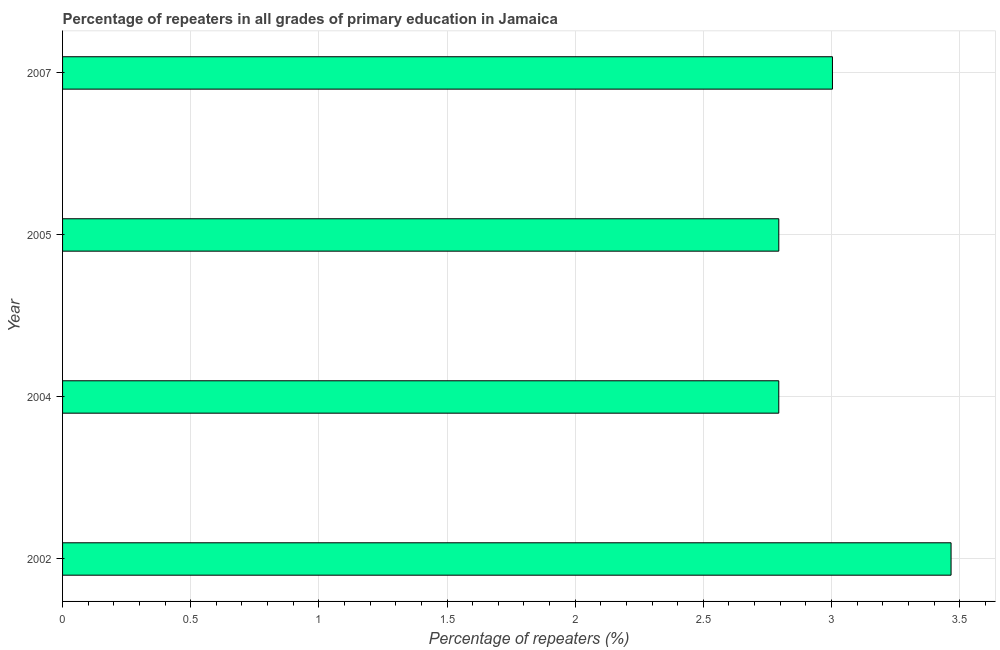What is the title of the graph?
Ensure brevity in your answer.  Percentage of repeaters in all grades of primary education in Jamaica. What is the label or title of the X-axis?
Keep it short and to the point. Percentage of repeaters (%). What is the percentage of repeaters in primary education in 2005?
Your answer should be compact. 2.79. Across all years, what is the maximum percentage of repeaters in primary education?
Keep it short and to the point. 3.47. Across all years, what is the minimum percentage of repeaters in primary education?
Make the answer very short. 2.79. In which year was the percentage of repeaters in primary education maximum?
Your answer should be compact. 2002. What is the sum of the percentage of repeaters in primary education?
Your response must be concise. 12.06. What is the difference between the percentage of repeaters in primary education in 2002 and 2005?
Offer a terse response. 0.67. What is the average percentage of repeaters in primary education per year?
Your answer should be compact. 3.02. What is the median percentage of repeaters in primary education?
Your answer should be compact. 2.9. What is the ratio of the percentage of repeaters in primary education in 2002 to that in 2004?
Make the answer very short. 1.24. Is the percentage of repeaters in primary education in 2002 less than that in 2007?
Offer a very short reply. No. Is the difference between the percentage of repeaters in primary education in 2004 and 2007 greater than the difference between any two years?
Offer a very short reply. No. What is the difference between the highest and the second highest percentage of repeaters in primary education?
Provide a short and direct response. 0.46. What is the difference between the highest and the lowest percentage of repeaters in primary education?
Your answer should be compact. 0.67. In how many years, is the percentage of repeaters in primary education greater than the average percentage of repeaters in primary education taken over all years?
Provide a short and direct response. 1. How many bars are there?
Provide a short and direct response. 4. Are all the bars in the graph horizontal?
Keep it short and to the point. Yes. How many years are there in the graph?
Provide a succinct answer. 4. What is the difference between two consecutive major ticks on the X-axis?
Your answer should be compact. 0.5. Are the values on the major ticks of X-axis written in scientific E-notation?
Offer a terse response. No. What is the Percentage of repeaters (%) of 2002?
Keep it short and to the point. 3.47. What is the Percentage of repeaters (%) of 2004?
Your response must be concise. 2.79. What is the Percentage of repeaters (%) of 2005?
Provide a succinct answer. 2.79. What is the Percentage of repeaters (%) in 2007?
Provide a short and direct response. 3. What is the difference between the Percentage of repeaters (%) in 2002 and 2004?
Give a very brief answer. 0.67. What is the difference between the Percentage of repeaters (%) in 2002 and 2005?
Make the answer very short. 0.67. What is the difference between the Percentage of repeaters (%) in 2002 and 2007?
Offer a terse response. 0.46. What is the difference between the Percentage of repeaters (%) in 2004 and 2005?
Your answer should be very brief. -7e-5. What is the difference between the Percentage of repeaters (%) in 2004 and 2007?
Keep it short and to the point. -0.21. What is the difference between the Percentage of repeaters (%) in 2005 and 2007?
Make the answer very short. -0.21. What is the ratio of the Percentage of repeaters (%) in 2002 to that in 2004?
Your answer should be compact. 1.24. What is the ratio of the Percentage of repeaters (%) in 2002 to that in 2005?
Offer a terse response. 1.24. What is the ratio of the Percentage of repeaters (%) in 2002 to that in 2007?
Offer a terse response. 1.15. 